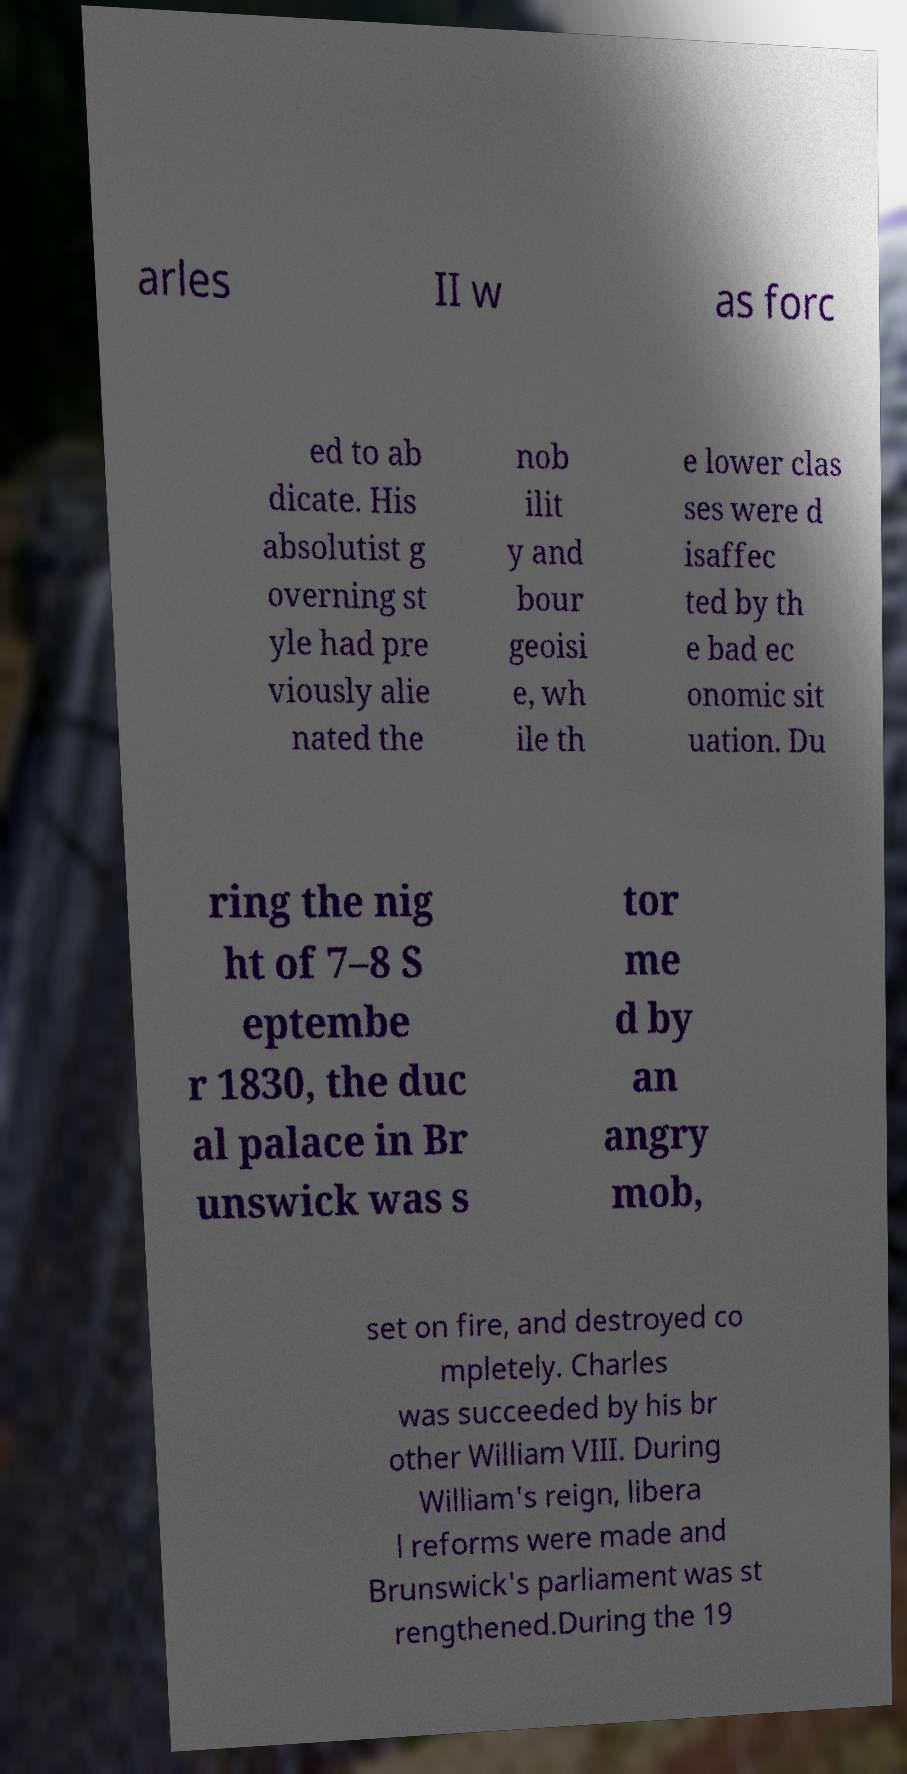There's text embedded in this image that I need extracted. Can you transcribe it verbatim? arles II w as forc ed to ab dicate. His absolutist g overning st yle had pre viously alie nated the nob ilit y and bour geoisi e, wh ile th e lower clas ses were d isaffec ted by th e bad ec onomic sit uation. Du ring the nig ht of 7–8 S eptembe r 1830, the duc al palace in Br unswick was s tor me d by an angry mob, set on fire, and destroyed co mpletely. Charles was succeeded by his br other William VIII. During William's reign, libera l reforms were made and Brunswick's parliament was st rengthened.During the 19 